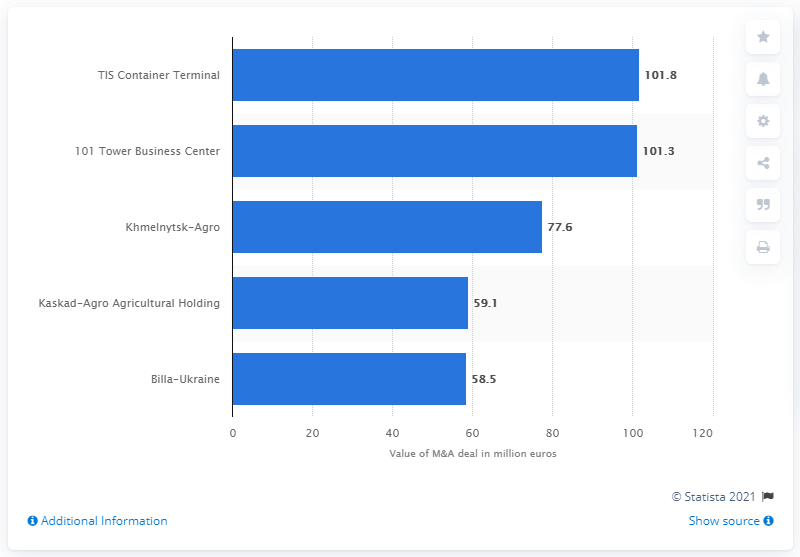What was the value of Billa-Ukraine?
 58.5 